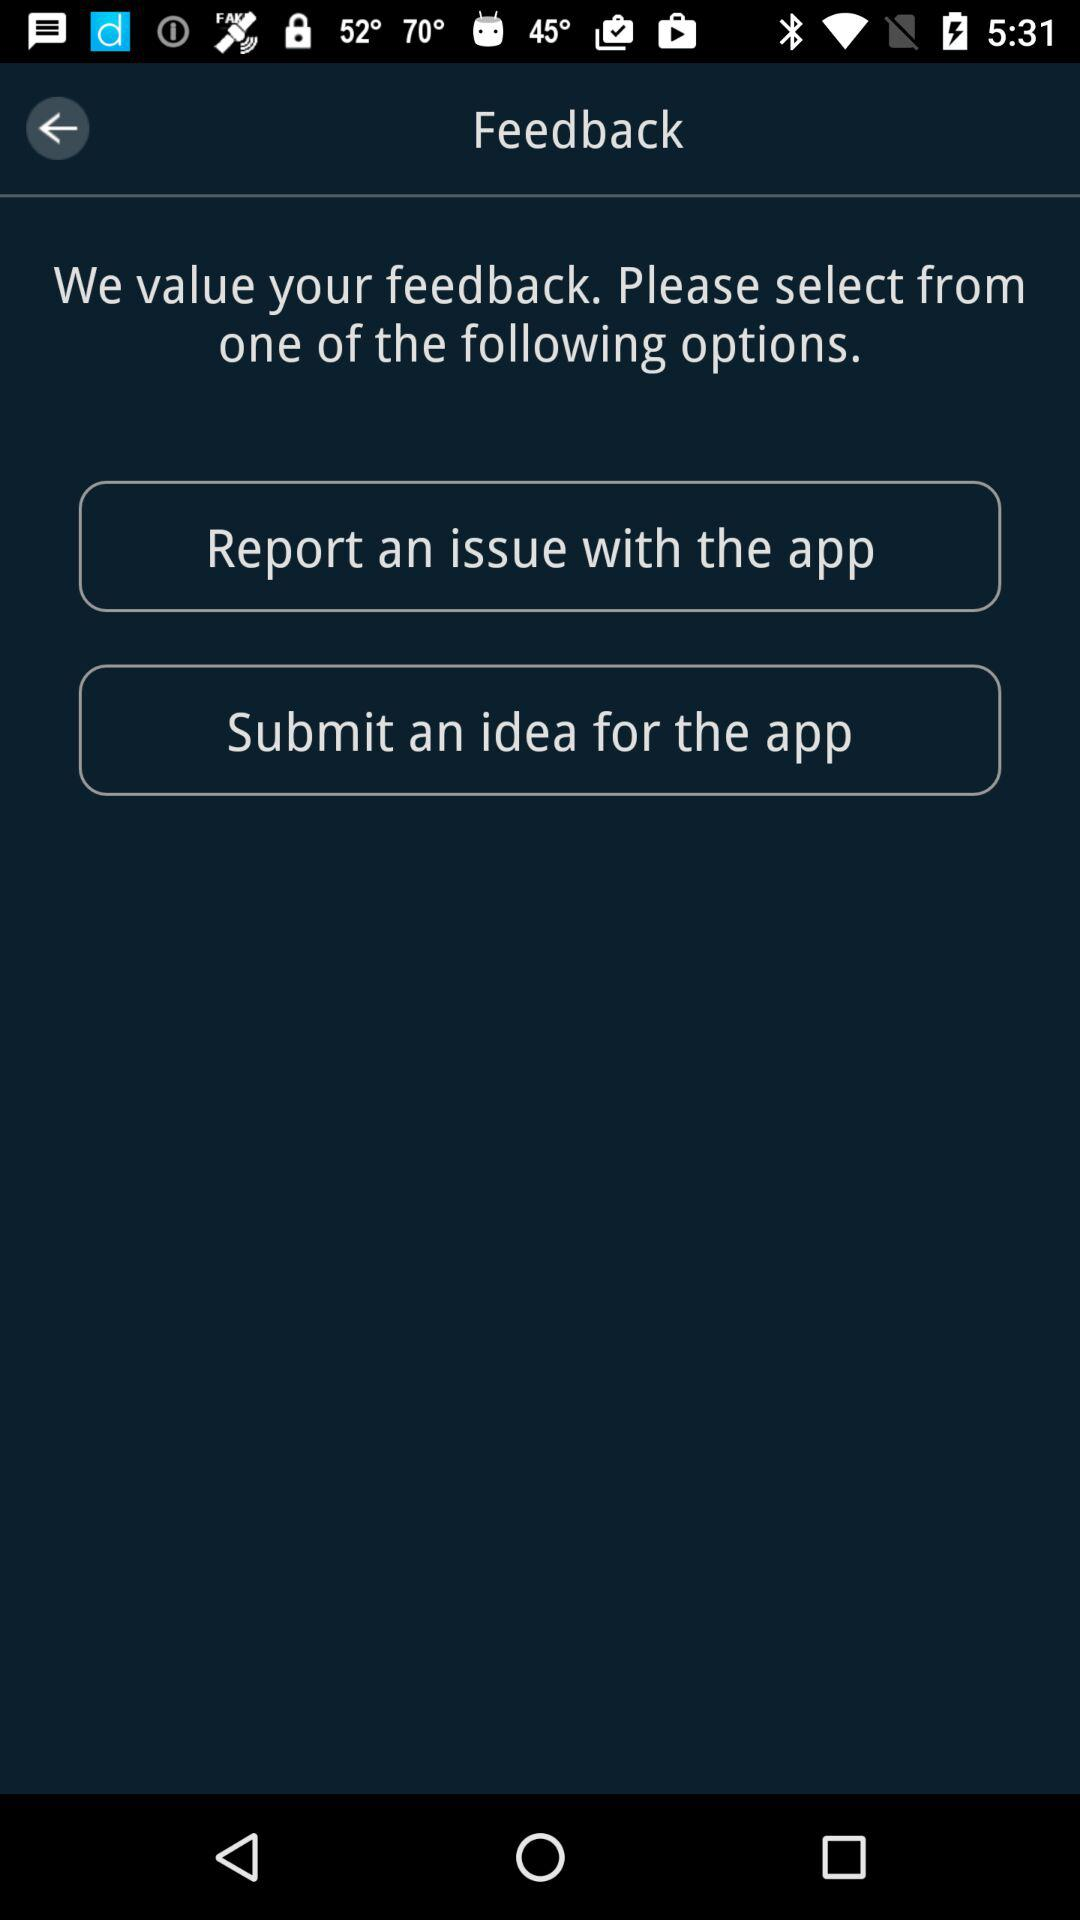What are the options available to select for feedback? The available options are "Report an issue with the app" and "Submit an idea for the app". 